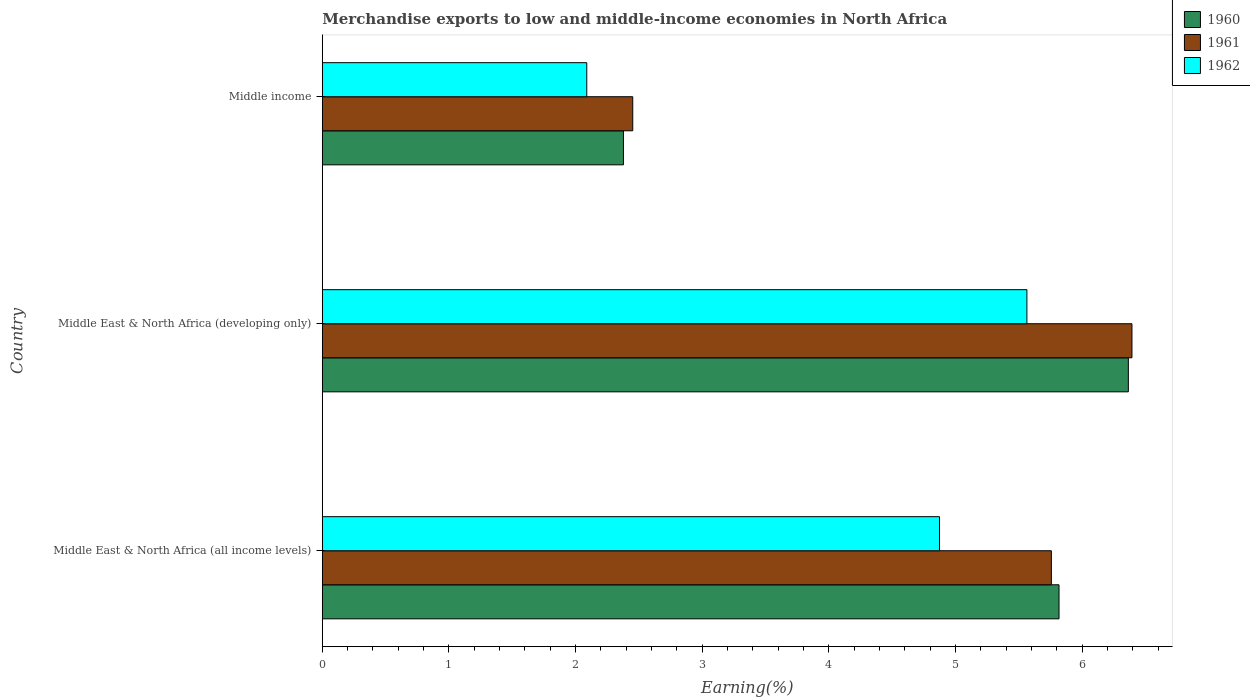Are the number of bars per tick equal to the number of legend labels?
Ensure brevity in your answer.  Yes. How many bars are there on the 2nd tick from the bottom?
Your response must be concise. 3. What is the label of the 2nd group of bars from the top?
Offer a terse response. Middle East & North Africa (developing only). In how many cases, is the number of bars for a given country not equal to the number of legend labels?
Give a very brief answer. 0. What is the percentage of amount earned from merchandise exports in 1961 in Middle East & North Africa (all income levels)?
Give a very brief answer. 5.76. Across all countries, what is the maximum percentage of amount earned from merchandise exports in 1962?
Your answer should be compact. 5.56. Across all countries, what is the minimum percentage of amount earned from merchandise exports in 1960?
Offer a terse response. 2.38. In which country was the percentage of amount earned from merchandise exports in 1962 maximum?
Make the answer very short. Middle East & North Africa (developing only). What is the total percentage of amount earned from merchandise exports in 1962 in the graph?
Your answer should be very brief. 12.52. What is the difference between the percentage of amount earned from merchandise exports in 1961 in Middle East & North Africa (developing only) and that in Middle income?
Your answer should be compact. 3.94. What is the difference between the percentage of amount earned from merchandise exports in 1962 in Middle income and the percentage of amount earned from merchandise exports in 1960 in Middle East & North Africa (all income levels)?
Your response must be concise. -3.73. What is the average percentage of amount earned from merchandise exports in 1960 per country?
Offer a terse response. 4.85. What is the difference between the percentage of amount earned from merchandise exports in 1961 and percentage of amount earned from merchandise exports in 1962 in Middle East & North Africa (developing only)?
Your response must be concise. 0.83. What is the ratio of the percentage of amount earned from merchandise exports in 1962 in Middle East & North Africa (developing only) to that in Middle income?
Your answer should be very brief. 2.66. Is the percentage of amount earned from merchandise exports in 1962 in Middle East & North Africa (developing only) less than that in Middle income?
Offer a terse response. No. What is the difference between the highest and the second highest percentage of amount earned from merchandise exports in 1960?
Provide a succinct answer. 0.55. What is the difference between the highest and the lowest percentage of amount earned from merchandise exports in 1960?
Provide a succinct answer. 3.99. Is the sum of the percentage of amount earned from merchandise exports in 1962 in Middle East & North Africa (developing only) and Middle income greater than the maximum percentage of amount earned from merchandise exports in 1961 across all countries?
Your response must be concise. Yes. How many bars are there?
Your response must be concise. 9. What is the difference between two consecutive major ticks on the X-axis?
Your answer should be very brief. 1. Are the values on the major ticks of X-axis written in scientific E-notation?
Your response must be concise. No. Does the graph contain grids?
Offer a terse response. No. Where does the legend appear in the graph?
Your response must be concise. Top right. How are the legend labels stacked?
Make the answer very short. Vertical. What is the title of the graph?
Offer a terse response. Merchandise exports to low and middle-income economies in North Africa. What is the label or title of the X-axis?
Make the answer very short. Earning(%). What is the label or title of the Y-axis?
Offer a terse response. Country. What is the Earning(%) of 1960 in Middle East & North Africa (all income levels)?
Give a very brief answer. 5.82. What is the Earning(%) in 1961 in Middle East & North Africa (all income levels)?
Offer a very short reply. 5.76. What is the Earning(%) of 1962 in Middle East & North Africa (all income levels)?
Your response must be concise. 4.87. What is the Earning(%) of 1960 in Middle East & North Africa (developing only)?
Offer a terse response. 6.36. What is the Earning(%) in 1961 in Middle East & North Africa (developing only)?
Provide a short and direct response. 6.39. What is the Earning(%) of 1962 in Middle East & North Africa (developing only)?
Your response must be concise. 5.56. What is the Earning(%) of 1960 in Middle income?
Your answer should be very brief. 2.38. What is the Earning(%) of 1961 in Middle income?
Your answer should be compact. 2.45. What is the Earning(%) in 1962 in Middle income?
Your answer should be compact. 2.09. Across all countries, what is the maximum Earning(%) of 1960?
Ensure brevity in your answer.  6.36. Across all countries, what is the maximum Earning(%) of 1961?
Your response must be concise. 6.39. Across all countries, what is the maximum Earning(%) of 1962?
Give a very brief answer. 5.56. Across all countries, what is the minimum Earning(%) of 1960?
Your answer should be compact. 2.38. Across all countries, what is the minimum Earning(%) of 1961?
Offer a very short reply. 2.45. Across all countries, what is the minimum Earning(%) in 1962?
Your answer should be very brief. 2.09. What is the total Earning(%) of 1960 in the graph?
Offer a very short reply. 14.56. What is the total Earning(%) of 1961 in the graph?
Ensure brevity in your answer.  14.6. What is the total Earning(%) of 1962 in the graph?
Ensure brevity in your answer.  12.52. What is the difference between the Earning(%) in 1960 in Middle East & North Africa (all income levels) and that in Middle East & North Africa (developing only)?
Give a very brief answer. -0.55. What is the difference between the Earning(%) in 1961 in Middle East & North Africa (all income levels) and that in Middle East & North Africa (developing only)?
Provide a succinct answer. -0.64. What is the difference between the Earning(%) of 1962 in Middle East & North Africa (all income levels) and that in Middle East & North Africa (developing only)?
Offer a terse response. -0.69. What is the difference between the Earning(%) in 1960 in Middle East & North Africa (all income levels) and that in Middle income?
Your answer should be compact. 3.44. What is the difference between the Earning(%) in 1961 in Middle East & North Africa (all income levels) and that in Middle income?
Make the answer very short. 3.31. What is the difference between the Earning(%) of 1962 in Middle East & North Africa (all income levels) and that in Middle income?
Your response must be concise. 2.79. What is the difference between the Earning(%) in 1960 in Middle East & North Africa (developing only) and that in Middle income?
Your answer should be compact. 3.99. What is the difference between the Earning(%) in 1961 in Middle East & North Africa (developing only) and that in Middle income?
Your answer should be compact. 3.94. What is the difference between the Earning(%) of 1962 in Middle East & North Africa (developing only) and that in Middle income?
Offer a very short reply. 3.48. What is the difference between the Earning(%) in 1960 in Middle East & North Africa (all income levels) and the Earning(%) in 1961 in Middle East & North Africa (developing only)?
Offer a very short reply. -0.58. What is the difference between the Earning(%) in 1960 in Middle East & North Africa (all income levels) and the Earning(%) in 1962 in Middle East & North Africa (developing only)?
Offer a very short reply. 0.25. What is the difference between the Earning(%) of 1961 in Middle East & North Africa (all income levels) and the Earning(%) of 1962 in Middle East & North Africa (developing only)?
Keep it short and to the point. 0.19. What is the difference between the Earning(%) in 1960 in Middle East & North Africa (all income levels) and the Earning(%) in 1961 in Middle income?
Offer a very short reply. 3.37. What is the difference between the Earning(%) of 1960 in Middle East & North Africa (all income levels) and the Earning(%) of 1962 in Middle income?
Give a very brief answer. 3.73. What is the difference between the Earning(%) in 1961 in Middle East & North Africa (all income levels) and the Earning(%) in 1962 in Middle income?
Offer a terse response. 3.67. What is the difference between the Earning(%) of 1960 in Middle East & North Africa (developing only) and the Earning(%) of 1961 in Middle income?
Ensure brevity in your answer.  3.91. What is the difference between the Earning(%) of 1960 in Middle East & North Africa (developing only) and the Earning(%) of 1962 in Middle income?
Your answer should be very brief. 4.28. What is the difference between the Earning(%) in 1961 in Middle East & North Africa (developing only) and the Earning(%) in 1962 in Middle income?
Ensure brevity in your answer.  4.3. What is the average Earning(%) of 1960 per country?
Your response must be concise. 4.85. What is the average Earning(%) of 1961 per country?
Provide a short and direct response. 4.87. What is the average Earning(%) in 1962 per country?
Provide a succinct answer. 4.17. What is the difference between the Earning(%) of 1960 and Earning(%) of 1961 in Middle East & North Africa (all income levels)?
Keep it short and to the point. 0.06. What is the difference between the Earning(%) in 1960 and Earning(%) in 1962 in Middle East & North Africa (all income levels)?
Keep it short and to the point. 0.94. What is the difference between the Earning(%) of 1961 and Earning(%) of 1962 in Middle East & North Africa (all income levels)?
Provide a short and direct response. 0.88. What is the difference between the Earning(%) in 1960 and Earning(%) in 1961 in Middle East & North Africa (developing only)?
Keep it short and to the point. -0.03. What is the difference between the Earning(%) in 1960 and Earning(%) in 1962 in Middle East & North Africa (developing only)?
Ensure brevity in your answer.  0.8. What is the difference between the Earning(%) in 1961 and Earning(%) in 1962 in Middle East & North Africa (developing only)?
Ensure brevity in your answer.  0.83. What is the difference between the Earning(%) in 1960 and Earning(%) in 1961 in Middle income?
Offer a very short reply. -0.07. What is the difference between the Earning(%) in 1960 and Earning(%) in 1962 in Middle income?
Your response must be concise. 0.29. What is the difference between the Earning(%) of 1961 and Earning(%) of 1962 in Middle income?
Give a very brief answer. 0.36. What is the ratio of the Earning(%) in 1960 in Middle East & North Africa (all income levels) to that in Middle East & North Africa (developing only)?
Provide a short and direct response. 0.91. What is the ratio of the Earning(%) of 1961 in Middle East & North Africa (all income levels) to that in Middle East & North Africa (developing only)?
Offer a terse response. 0.9. What is the ratio of the Earning(%) in 1962 in Middle East & North Africa (all income levels) to that in Middle East & North Africa (developing only)?
Ensure brevity in your answer.  0.88. What is the ratio of the Earning(%) in 1960 in Middle East & North Africa (all income levels) to that in Middle income?
Your response must be concise. 2.45. What is the ratio of the Earning(%) in 1961 in Middle East & North Africa (all income levels) to that in Middle income?
Offer a terse response. 2.35. What is the ratio of the Earning(%) of 1962 in Middle East & North Africa (all income levels) to that in Middle income?
Your answer should be very brief. 2.33. What is the ratio of the Earning(%) of 1960 in Middle East & North Africa (developing only) to that in Middle income?
Keep it short and to the point. 2.68. What is the ratio of the Earning(%) of 1961 in Middle East & North Africa (developing only) to that in Middle income?
Ensure brevity in your answer.  2.61. What is the ratio of the Earning(%) of 1962 in Middle East & North Africa (developing only) to that in Middle income?
Your answer should be compact. 2.66. What is the difference between the highest and the second highest Earning(%) in 1960?
Give a very brief answer. 0.55. What is the difference between the highest and the second highest Earning(%) of 1961?
Your response must be concise. 0.64. What is the difference between the highest and the second highest Earning(%) of 1962?
Give a very brief answer. 0.69. What is the difference between the highest and the lowest Earning(%) of 1960?
Your answer should be compact. 3.99. What is the difference between the highest and the lowest Earning(%) in 1961?
Give a very brief answer. 3.94. What is the difference between the highest and the lowest Earning(%) of 1962?
Your answer should be very brief. 3.48. 